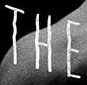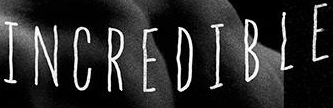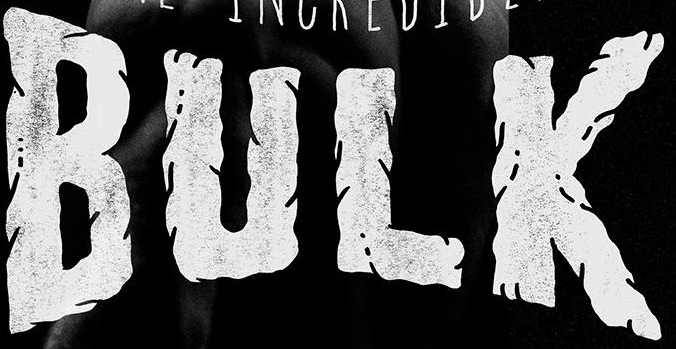What text is displayed in these images sequentially, separated by a semicolon? THE; INCREDIBLE; BULK 